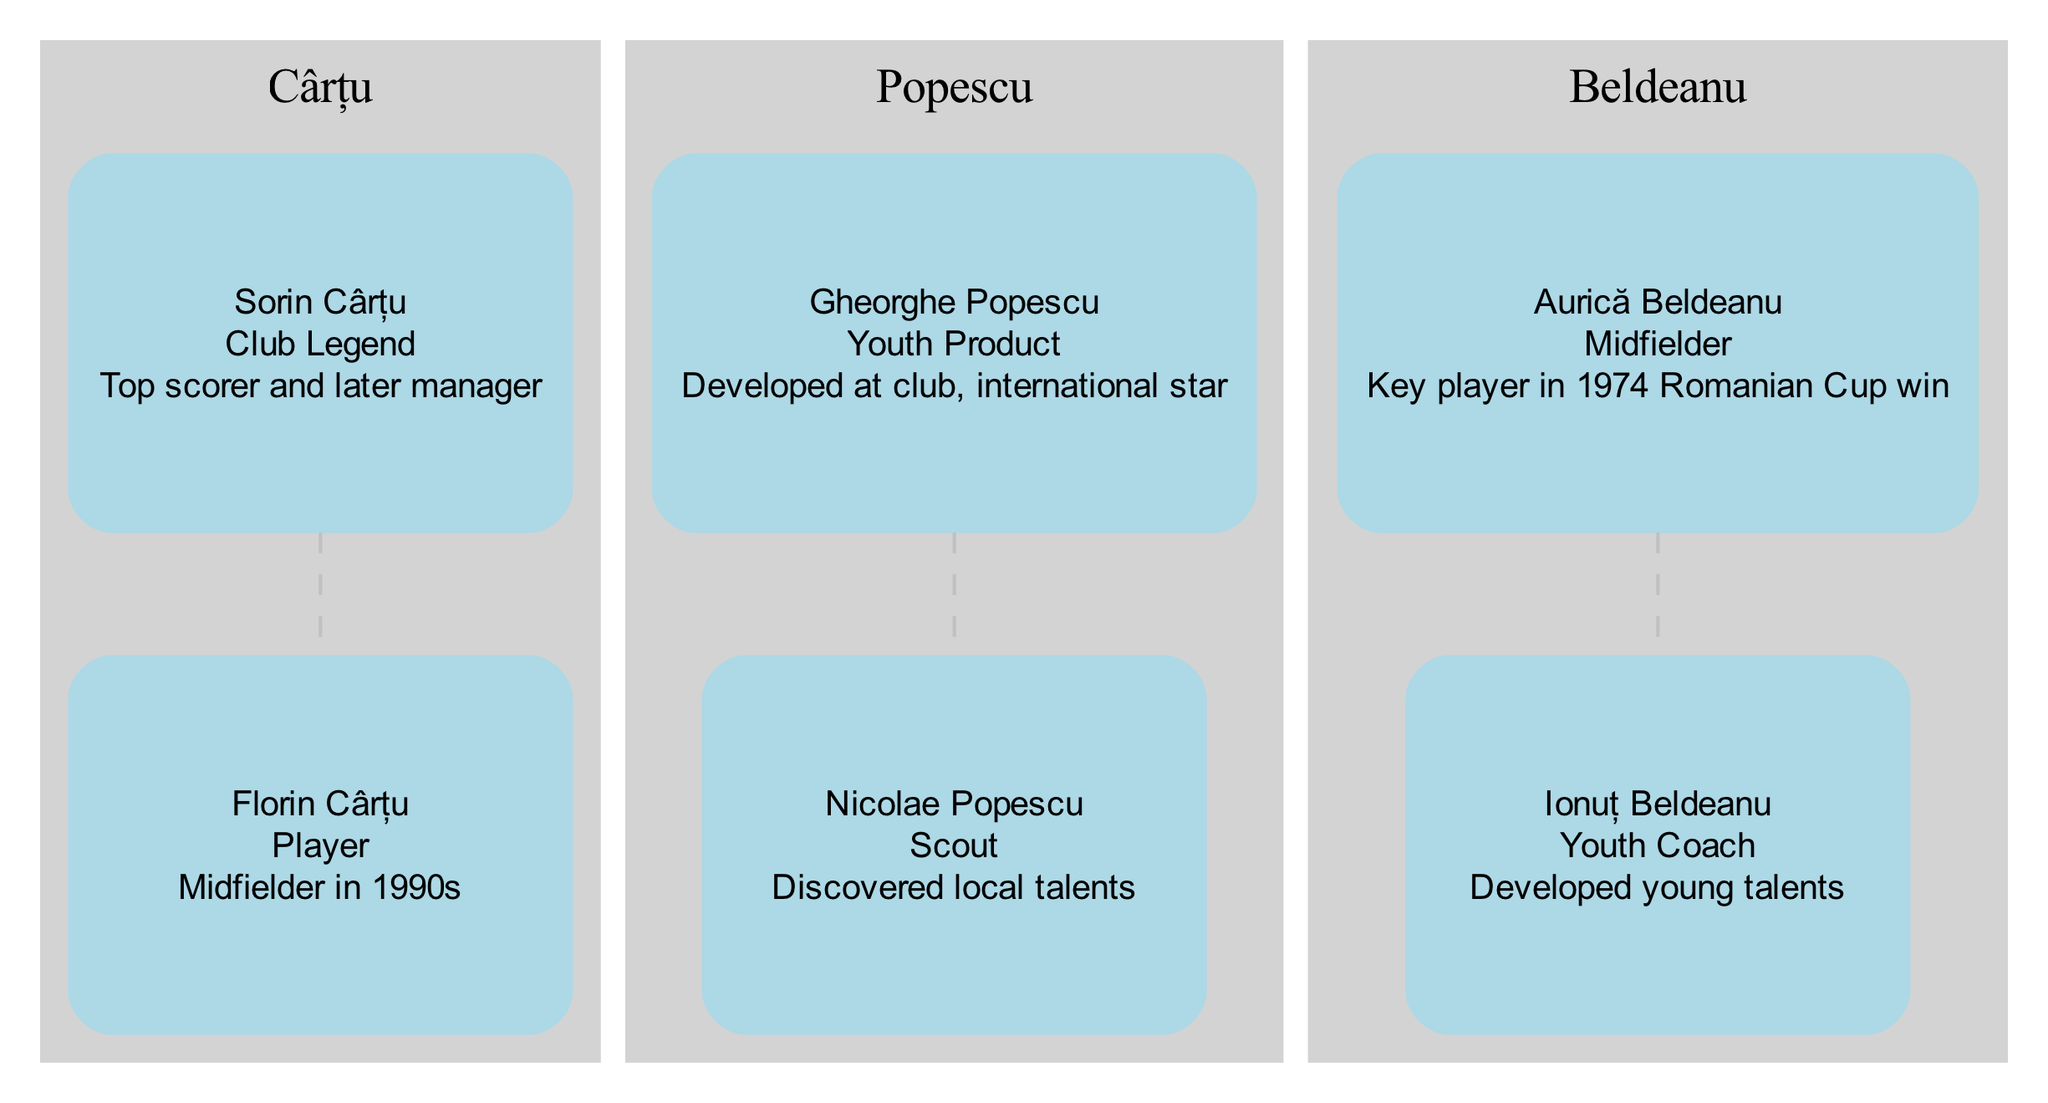What is the name of the oldest football family in the diagram? The diagram lists three families: Cârțu, Popescu, and Beldeanu. However, the diagram does not indicate the founding dates. In this case, we can infer that Cârțu is the oldest based on its prominence in the contributions.
Answer: Cârțu How many members are there in the Beldeanu family? The Beldeanu family has two members represented in the diagram: Aurică Beldeanu and Ionuț Beldeanu. By counting the nodes under the Beldeanu subgraph, we find there are two.
Answer: 2 Who is a key player in the 1974 Romanian Cup win? Aurică Beldeanu is mentioned as a key player in the 1974 Romanian Cup win according to the information listed in his node within the family tree.
Answer: Aurică Beldeanu Which family has a member who is a scout? The Popescu family has a member named Nicolae Popescu, who is identified as a scout responsible for discovering local talents in the diagram.
Answer: Popescu What role did Sorin Cârțu have in the club? Sorin Cârțu is noted as a club legend in the diagram. This information is directly taken from the description provided in his member node.
Answer: Club Legend How many youth coaches are listed in the diagram? There is one youth coach noted in the diagram, specifically Ionuț Beldeanu from the Beldeanu family. This is confirmed by counting the specific roles Mentioned in the contributions of each member.
Answer: 1 Which member contributed significantly as a midfielder in the 1990s? Florin Cârțu is recognized in the diagram for his role as a midfielder during the 1990s, which is stated in his member contribution.
Answer: Florin Cârțu What is Gheorghe Popescu's contribution to the club? Gheorghe Popescu is credited as a youth product who developed at the club and later became an international star. This information is highlighted in his member node.
Answer: Developed at club, international star What connection can be established between Sorin Cârțu and Florin Cârțu? The diagram visually represents a familial connection between Sorin Cârțu, the club legend, and Florin Cârțu, the midfielder in the 1990s, indicating they are part of the same family.
Answer: Family connection 